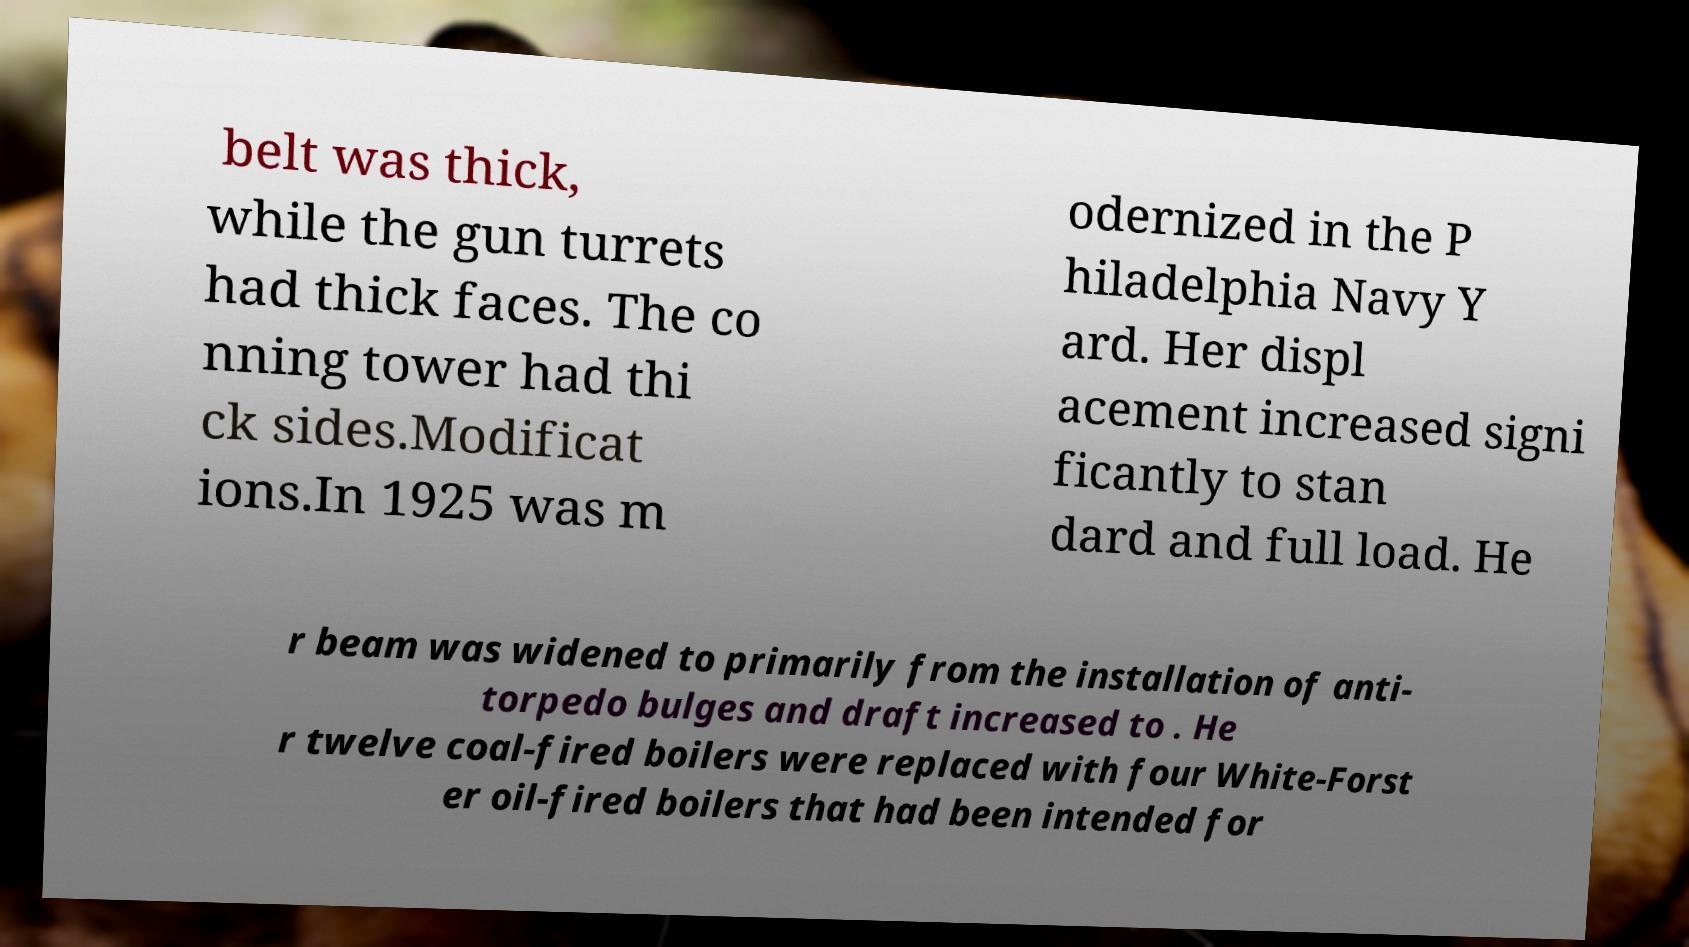Please identify and transcribe the text found in this image. belt was thick, while the gun turrets had thick faces. The co nning tower had thi ck sides.Modificat ions.In 1925 was m odernized in the P hiladelphia Navy Y ard. Her displ acement increased signi ficantly to stan dard and full load. He r beam was widened to primarily from the installation of anti- torpedo bulges and draft increased to . He r twelve coal-fired boilers were replaced with four White-Forst er oil-fired boilers that had been intended for 